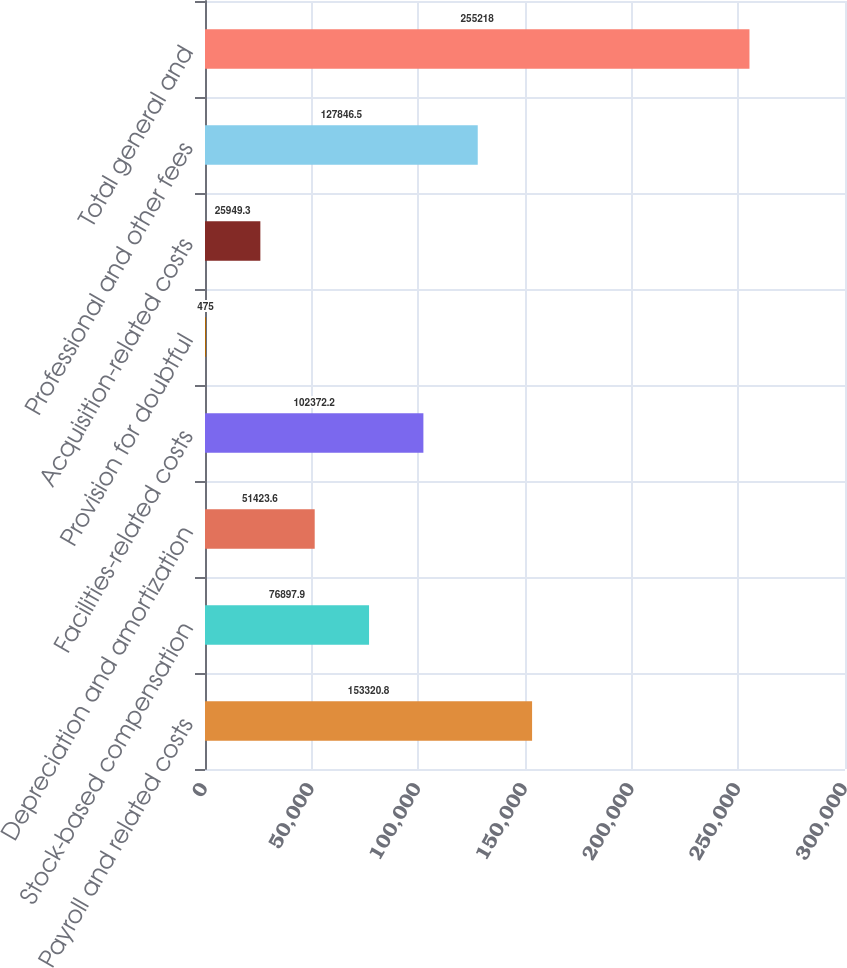<chart> <loc_0><loc_0><loc_500><loc_500><bar_chart><fcel>Payroll and related costs<fcel>Stock-based compensation<fcel>Depreciation and amortization<fcel>Facilities-related costs<fcel>Provision for doubtful<fcel>Acquisition-related costs<fcel>Professional and other fees<fcel>Total general and<nl><fcel>153321<fcel>76897.9<fcel>51423.6<fcel>102372<fcel>475<fcel>25949.3<fcel>127846<fcel>255218<nl></chart> 